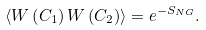Convert formula to latex. <formula><loc_0><loc_0><loc_500><loc_500>\langle W \left ( C _ { 1 } \right ) W \left ( C _ { 2 } \right ) \rangle = e ^ { - S _ { N G } } .</formula> 